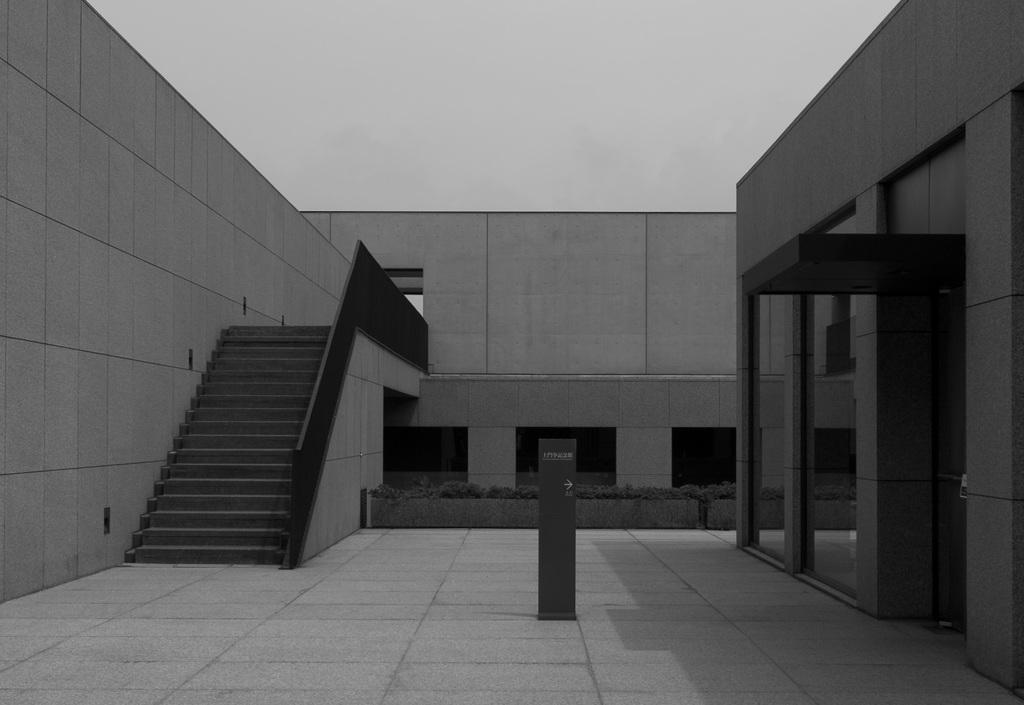What structure is located on the left side of the image? There is a staircase on the left side of the image. What type of walls can be seen on the right side of the image? There are glass walls on the right side of the image. What type of location is depicted in the image? The image depicts a construction site. What is visible at the top of the image? The sky is visible at the top of the image. What type of grain is being harvested at the construction site in the image? There is no grain being harvested in the image; it depicts a construction site. What design elements can be seen on the back of the glass walls in the image? There are no design elements mentioned on the back of the glass walls, as the focus is on the glass walls themselves. 